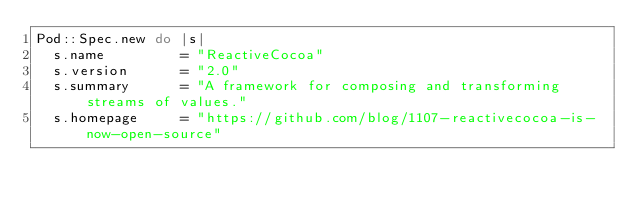Convert code to text. <code><loc_0><loc_0><loc_500><loc_500><_Ruby_>Pod::Spec.new do |s|
  s.name         = "ReactiveCocoa"
  s.version      = "2.0"
  s.summary      = "A framework for composing and transforming streams of values."
  s.homepage     = "https://github.com/blog/1107-reactivecocoa-is-now-open-source"</code> 